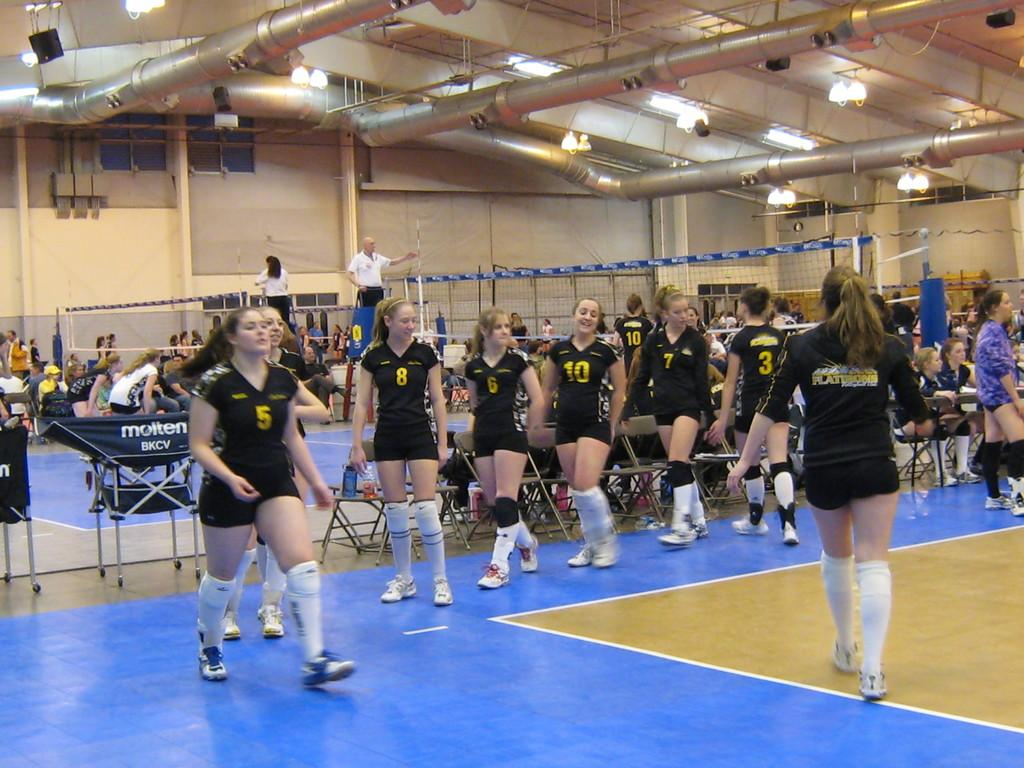<image>
Give a short and clear explanation of the subsequent image. Several girls with different numbers parade including number 5, 8 and 10. 